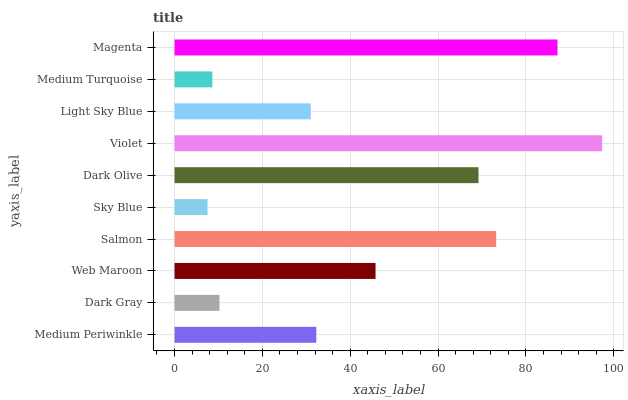Is Sky Blue the minimum?
Answer yes or no. Yes. Is Violet the maximum?
Answer yes or no. Yes. Is Dark Gray the minimum?
Answer yes or no. No. Is Dark Gray the maximum?
Answer yes or no. No. Is Medium Periwinkle greater than Dark Gray?
Answer yes or no. Yes. Is Dark Gray less than Medium Periwinkle?
Answer yes or no. Yes. Is Dark Gray greater than Medium Periwinkle?
Answer yes or no. No. Is Medium Periwinkle less than Dark Gray?
Answer yes or no. No. Is Web Maroon the high median?
Answer yes or no. Yes. Is Medium Periwinkle the low median?
Answer yes or no. Yes. Is Violet the high median?
Answer yes or no. No. Is Dark Olive the low median?
Answer yes or no. No. 